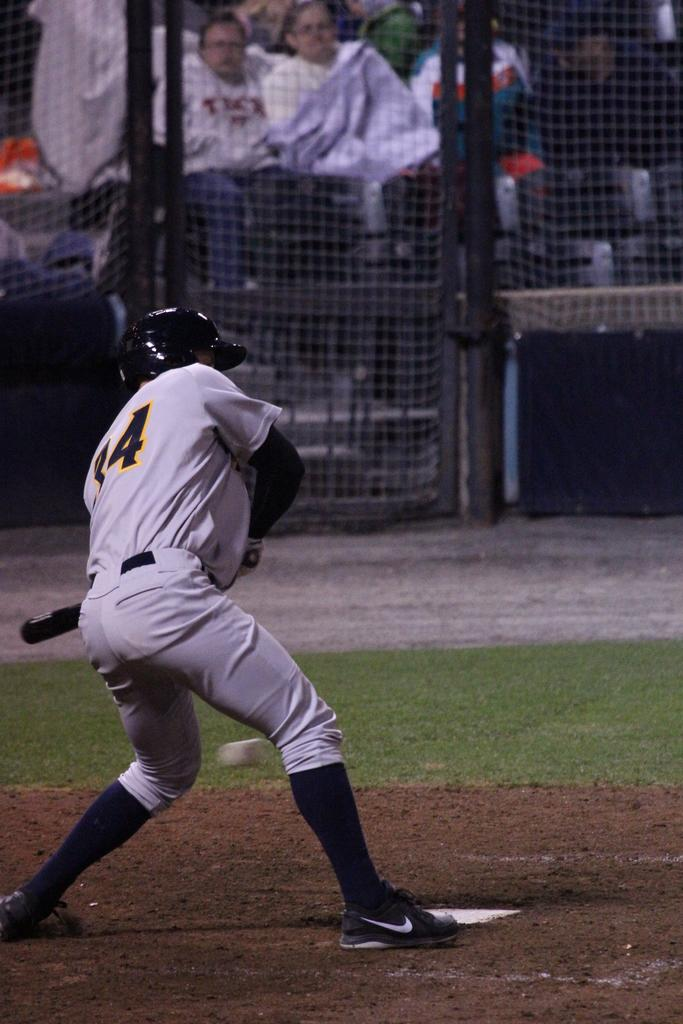<image>
Present a compact description of the photo's key features. Number 34 reads the jersey of the player at the plate. 